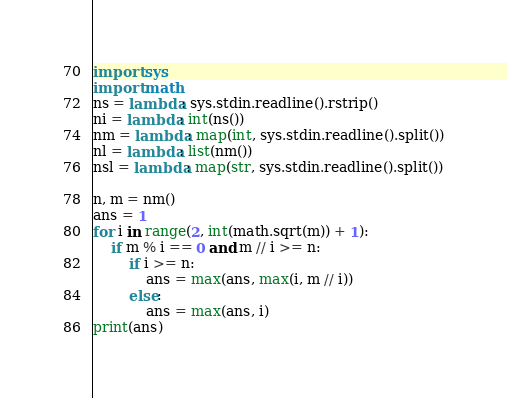<code> <loc_0><loc_0><loc_500><loc_500><_Python_>import sys
import math
ns = lambda: sys.stdin.readline().rstrip()
ni = lambda: int(ns())
nm = lambda: map(int, sys.stdin.readline().split())
nl = lambda: list(nm())
nsl = lambda: map(str, sys.stdin.readline().split())

n, m = nm()
ans = 1
for i in range(2, int(math.sqrt(m)) + 1):
    if m % i == 0 and m // i >= n:
        if i >= n:
            ans = max(ans, max(i, m // i))
        else:
            ans = max(ans, i)
print(ans)
</code> 